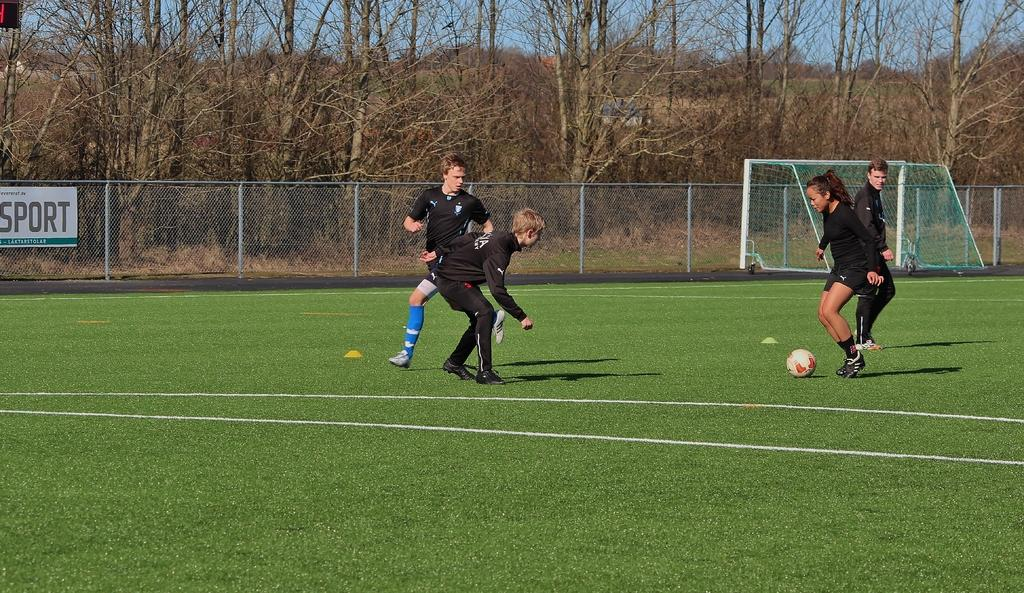How many people are playing football in the image? There are four persons in the image. What are the persons in the image doing? The persons are playing football. What can be seen in the background of the image? There is a board, a wire fence, a football net, trees, and the sky visible in the background of the image. What type of needle is being used to make a quarter in the image? There is no needle or quarter present in the image; it features four persons playing football with a football net, board, wire fence, trees, and sky visible in the background. --- Facts: 1. There is a person holding a book in the image. 2. The book has a blue cover. 3. The person is sitting on a chair. 4. There is a table in the image. 5. The table has a lamp on it. Absurd Topics: elephant, ocean, dance Conversation: What is the person in the image holding? The person is holding a book in the image. What color is the book's cover? The book has a blue cover. Where is the person sitting? The person is sitting on a chair. What can be seen on the table in the image? There is a lamp on the table in the image. Reasoning: Let's think step by step in order to produce the conversation. We start by identifying the main subject of the image, which is the person holding a book. Then, we describe the book's specific features, such as its blue cover. Next, we mention the person's location, which is sitting on a chair. Finally, we expand the conversation to include the table and the lamp present on it. Each question is designed to elicit a specific detail about the image that is known from the provided facts. Absurd Question/Answer: Can you see an elephant swimming in the ocean in the image? There is no elephant or ocean present in the image; it features a person holding a blue-covered book, sitting on a chair, and a table with a lamp on it. 